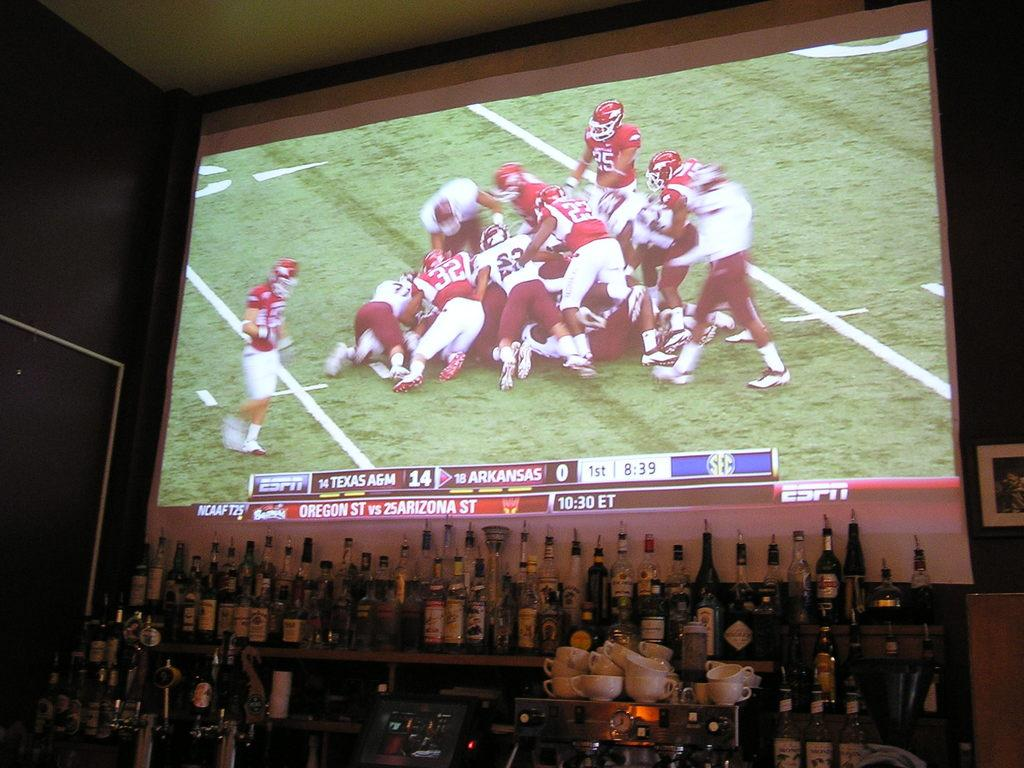<image>
Describe the image concisely. Football game on a projector with Texas A&M winning 14 to 0 against Arkansas 